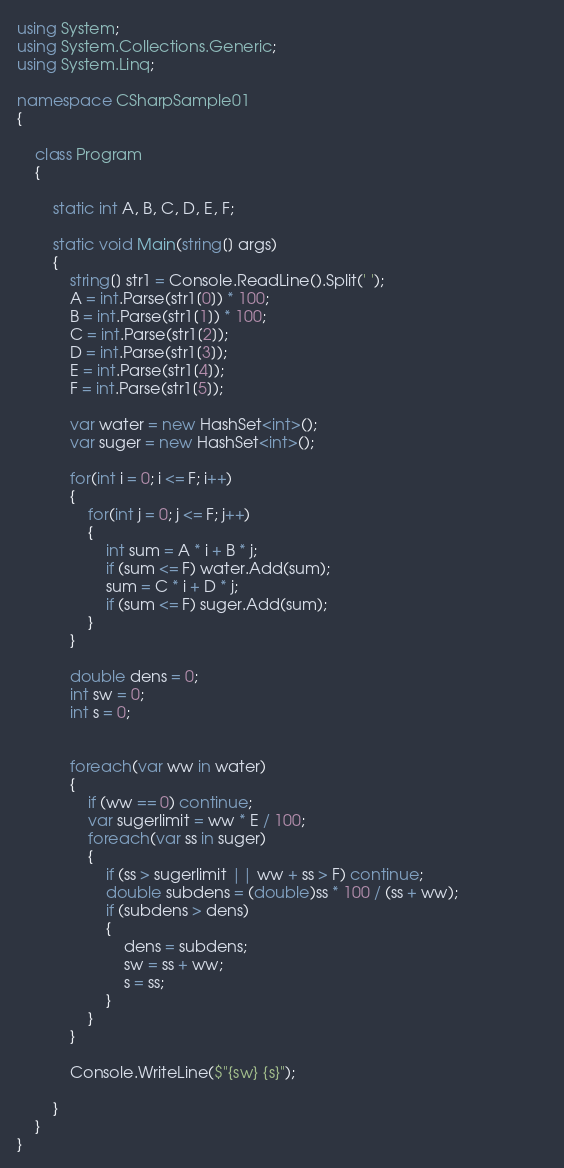<code> <loc_0><loc_0><loc_500><loc_500><_C#_>using System;
using System.Collections.Generic;
using System.Linq;

namespace CSharpSample01
{

    class Program
    {

        static int A, B, C, D, E, F;
   
        static void Main(string[] args)
        {
            string[] str1 = Console.ReadLine().Split(' ');
            A = int.Parse(str1[0]) * 100;
            B = int.Parse(str1[1]) * 100;
            C = int.Parse(str1[2]);
            D = int.Parse(str1[3]);
            E = int.Parse(str1[4]);
            F = int.Parse(str1[5]);

            var water = new HashSet<int>();
            var suger = new HashSet<int>();            

            for(int i = 0; i <= F; i++)
            {
                for(int j = 0; j <= F; j++)
                {
                    int sum = A * i + B * j;
                    if (sum <= F) water.Add(sum);
                    sum = C * i + D * j;
                    if (sum <= F) suger.Add(sum);
                }
            }

            double dens = 0;
            int sw = 0;
            int s = 0;


            foreach(var ww in water)
            {
                if (ww == 0) continue;
                var sugerlimit = ww * E / 100;                
                foreach(var ss in suger)
                {                   
                    if (ss > sugerlimit || ww + ss > F) continue;
                    double subdens = (double)ss * 100 / (ss + ww);                    
                    if (subdens > dens)
                    {                       
                        dens = subdens;
                        sw = ss + ww;
                        s = ss;
                    }
                }
            }
            
            Console.WriteLine($"{sw} {s}");

        }
    }
}
</code> 